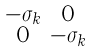<formula> <loc_0><loc_0><loc_500><loc_500>\begin{smallmatrix} - \sigma _ { k } & 0 \\ 0 & - \sigma _ { k } \end{smallmatrix}</formula> 